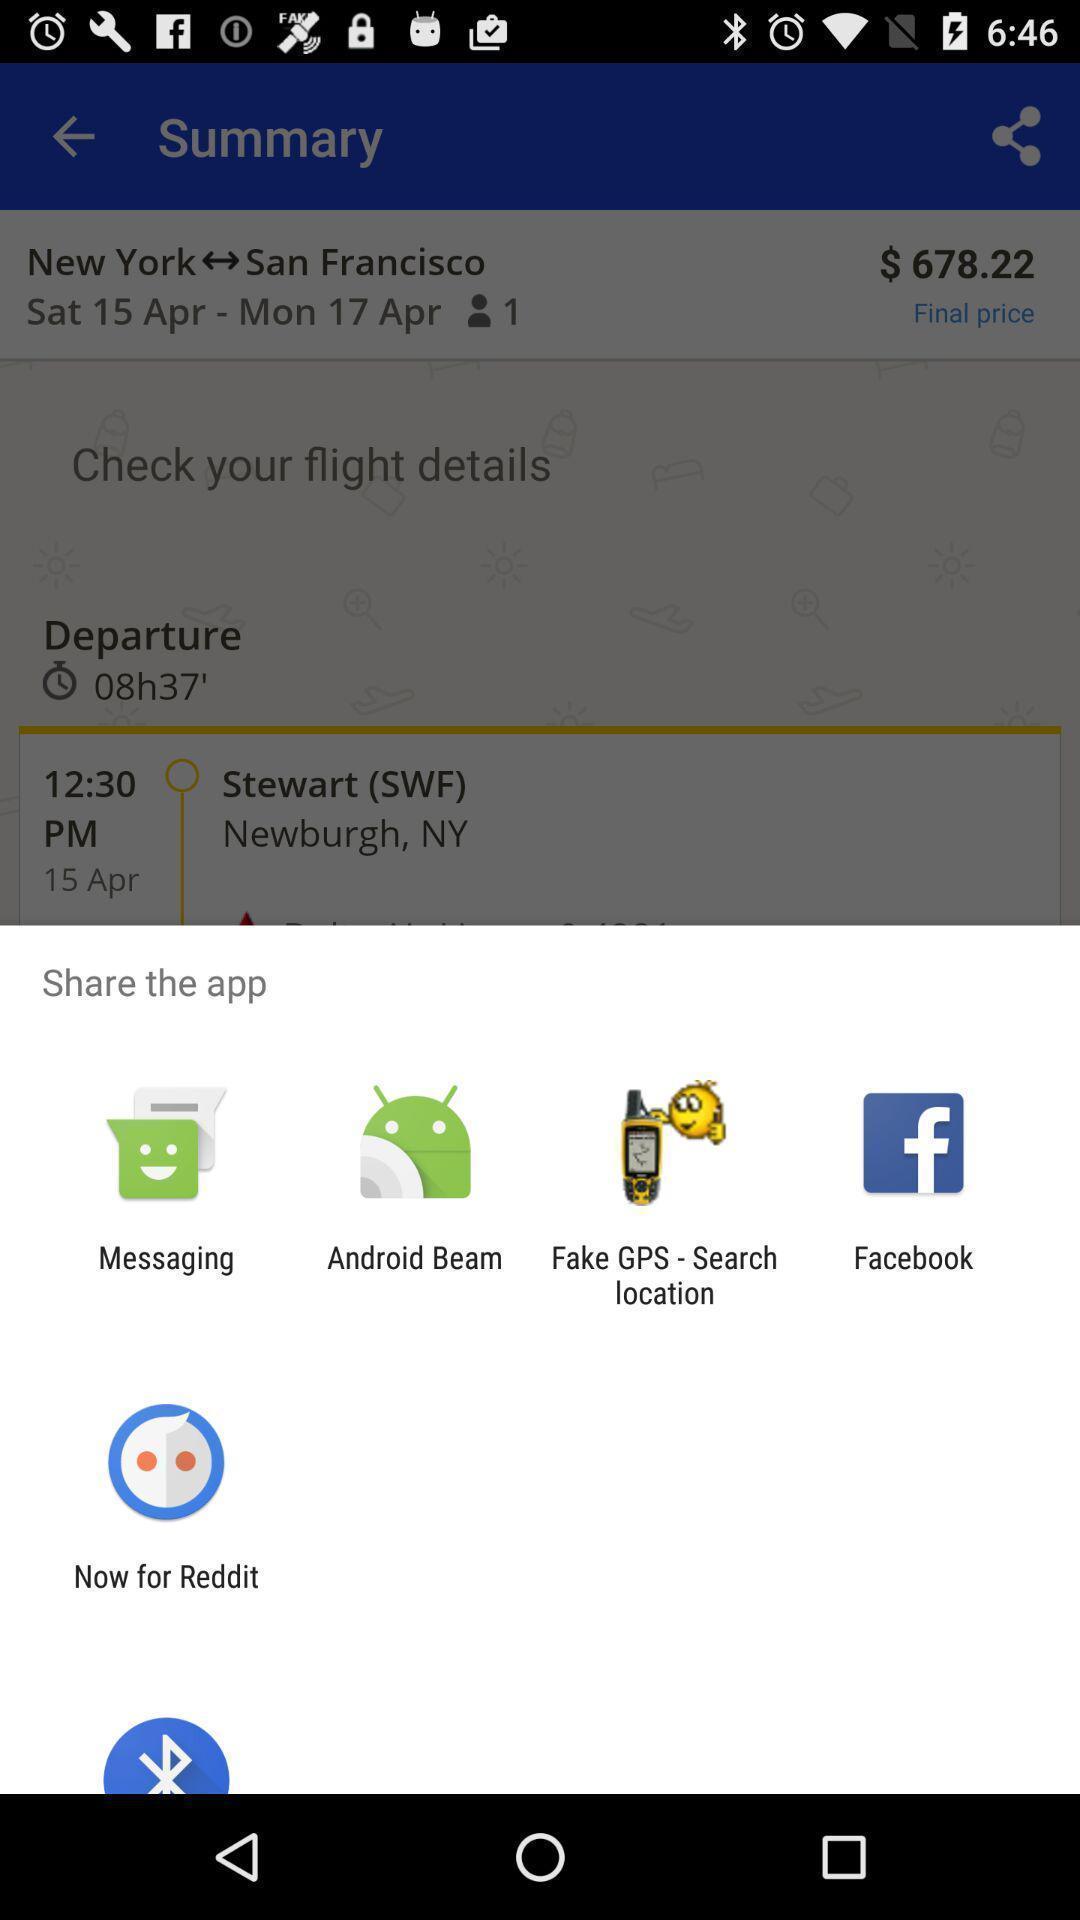Summarize the information in this screenshot. Popup to share the travel app. 